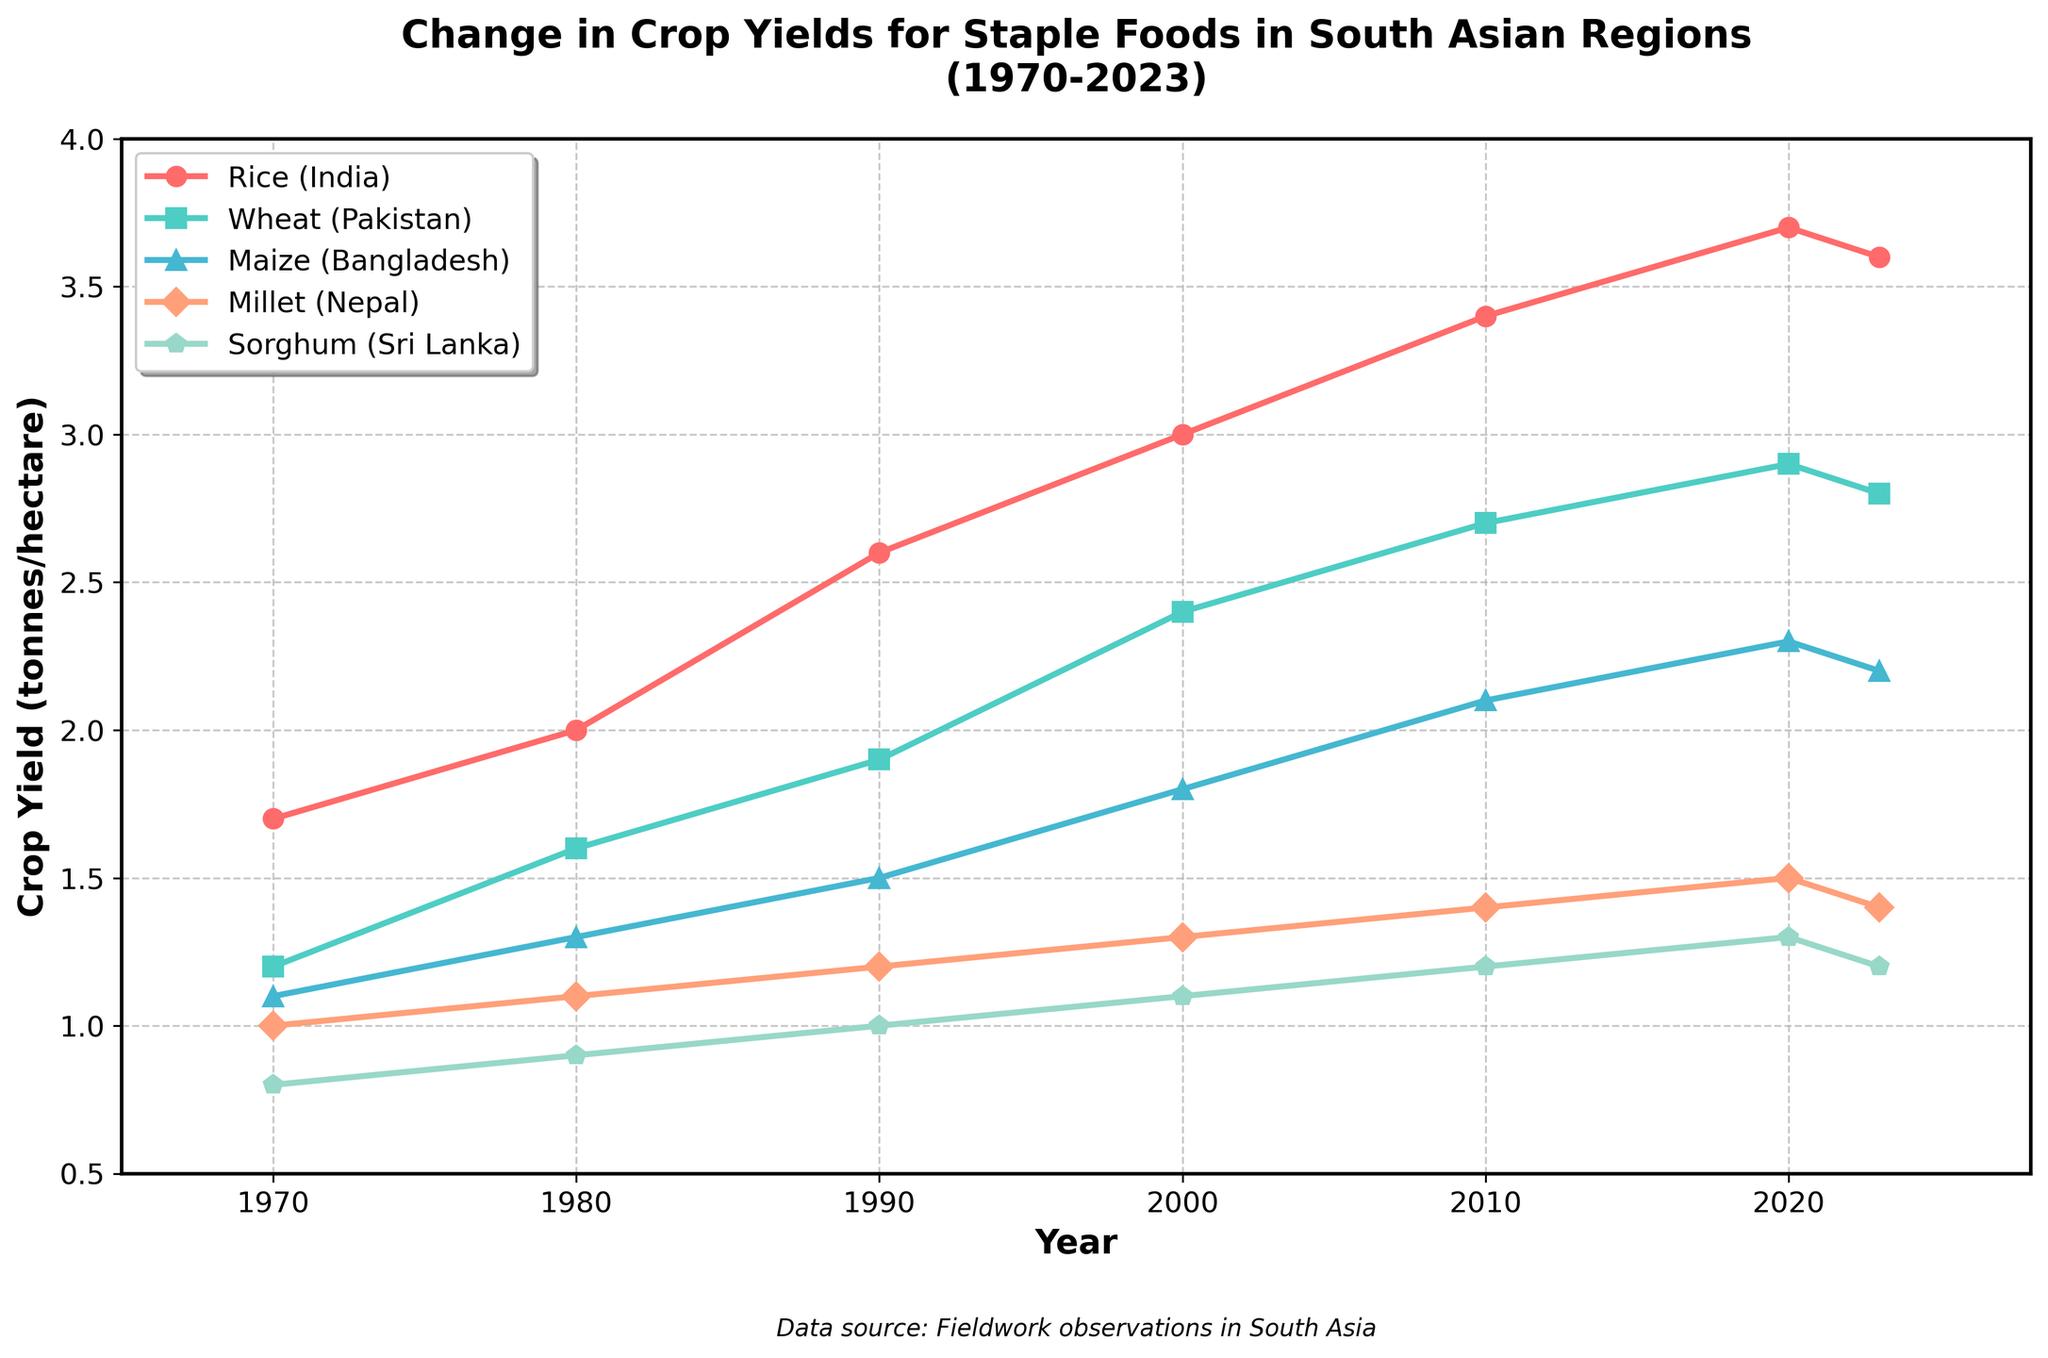What trend can be observed for Rice yields in India from 1970 to 2023? By looking at the line representing Rice (India), we can observe that the crop yield increased steadily from 1.7 tonnes/hectare in 1970 to a peak of 3.7 tonnes/hectare in 2020, followed by a slight decrease to 3.6 tonnes/hectare in 2023.
Answer: Steady increase, slight decrease in recent years Which crop showed the least improvement in yield from 1970 to 2023 among the five? By comparing the starting and ending points of each line, we can see that Sorghum (Sri Lanka) increased only from 0.8 to 1.2 tonnes/hectare, which is the smallest change compared to the other crops.
Answer: Sorghum (Sri Lanka) In what year did Wheat yields in Pakistan first reach 2 tonnes/hectare? To find this, follow the line for Wheat (Pakistan) and locate the point where it crosses the 2 tonnes/hectare mark, which occurs in the year 2000.
Answer: 2000 What is the average yield for Maize (Bangladesh) across the years shown? Calculate the average by adding yields for each year (1.1, 1.3, 1.5, 1.8, 2.1, 2.3, 2.2) and then dividing by the number of years (7). The sum is 12.3, and 12.3/7 is approximately 1.76 tonnes/hectare.
Answer: Approximately 1.76 tonnes/hectare Which crop had the largest increase in yield between 1980 and 2000? Calculate the difference between the yields in 1980 and 2000 for each crop: 
   - Rice (India): 3.0 - 2.0 = 1.0
   - Wheat (Pakistan): 2.4 - 1.6 = 0.8 
   - Maize (Bangladesh): 1.8 - 1.3 = 0.5 
   - Millet (Nepal): 1.3 - 1.1 = 0.2 
   - Sorghum (Sri Lanka): 1.1 - 0.9 = 0.2
The largest increase is for Rice (India) with an increase of 1.0 tonnes/hectare.
Answer: Rice (India) When did Millet (Nepal) experience a yield above 1.2 tonnes/hectare for the first time? Observing the line for Millet (Nepal), we see that it crosses above 1.2 tonnes/hectare between 1990 and 2000, first recorded in the year 2000.
Answer: 2000 Which crop showed a consistent increase in every decade from 1970 to 2020? Analyze each crop line to see if yields rose in each interval. Rice (India) satisfies this as its yield increased every decade from 1970 to 2020.
Answer: Rice (India) What was the difference in yield between the highest and lowest yielding crops in 2010? In 2010:
   - Highest: Rice (India) at 3.4 tonnes/hectare
   - Lowest: Sorghum (Sri Lanka) at 1.2 tonnes/hectare
   The difference is 3.4 - 1.2 = 2.2 tonnes/hectare.
Answer: 2.2 tonnes/hectare 